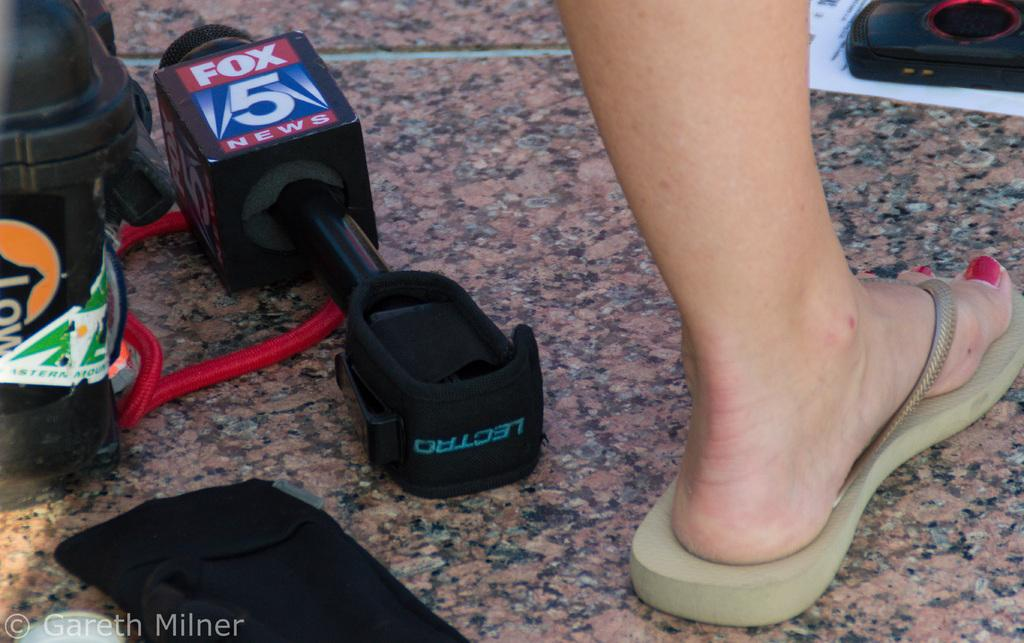What type of surface is present in the image? There is a floor in the image. What part of a person can be seen in the image? A human leg is visible in the image. What object is used for amplifying sound in the image? There is a mic in the image. What container is present in the image? There is a bottle in the image. What type of side dish is being served in the image? There is no side dish present in the image. Can you tell me the name of the judge in the image? There is no judge present in the image. 